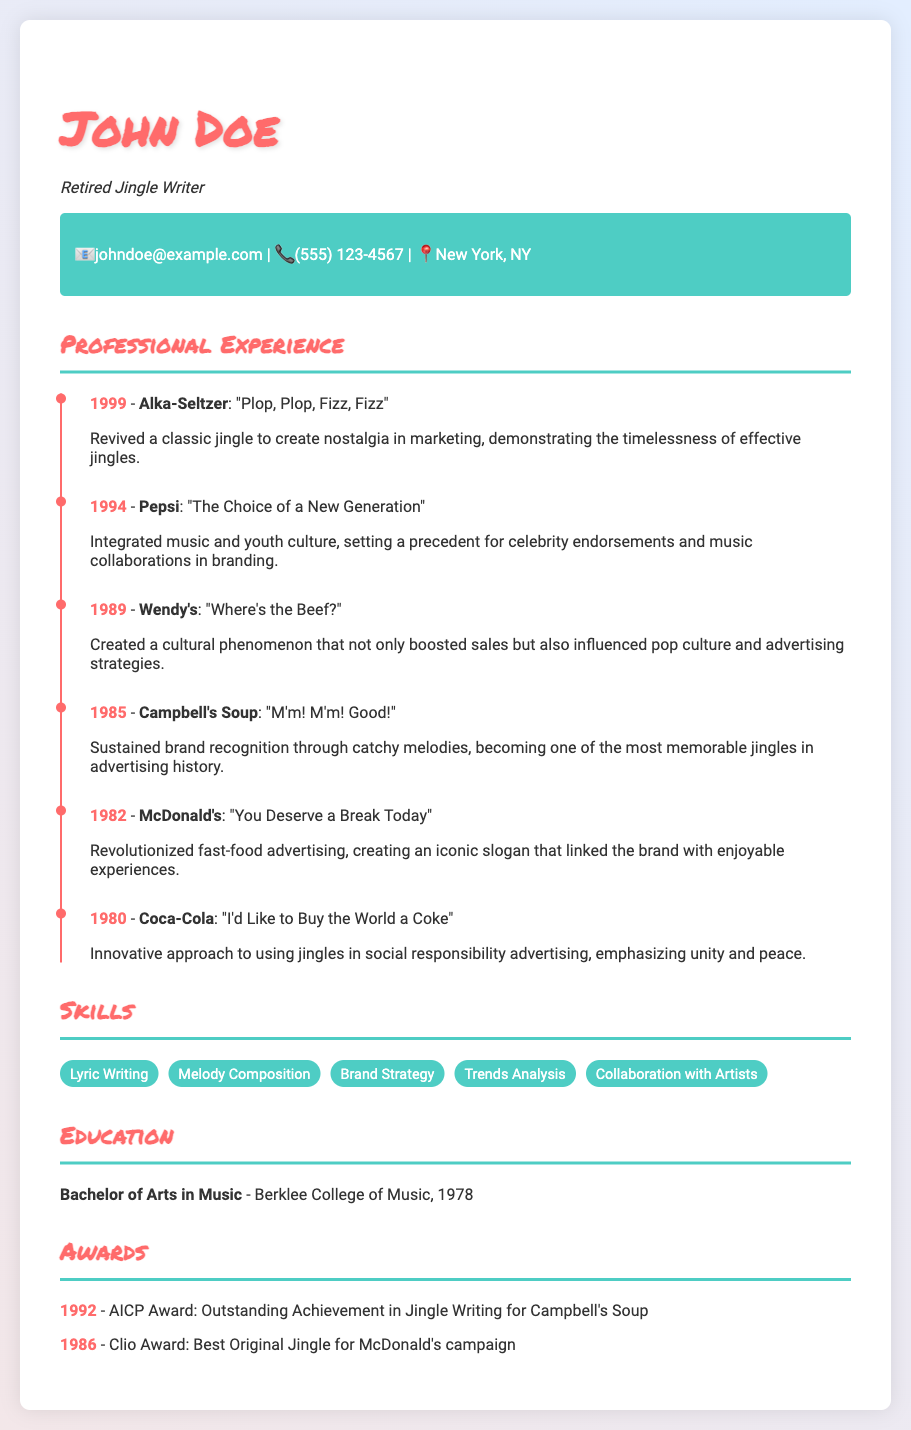what notable jingle was created for Coca-Cola in 1980? The document states that the jingle for Coca-Cola was "I'd Like to Buy the World a Coke."
Answer: I'd Like to Buy the World a Coke which company’s jingle included "Where's the Beef?" and was created in 1989? According to the document, the jingle "Where's the Beef?" was created for Wendy's in 1989.
Answer: Wendy's what year did John Doe write the jingle for McDonald's? The timeline in the document indicates that the jingle for McDonald's was written in 1982.
Answer: 1982 what is the total number of awards listed in the CV? The document lists two awards: the AICP Award and the Clio Award under the Awards section.
Answer: 2 which skill is associated with creating catchy melodies? The skills section mentions "Melody Composition" as a relevant skill for creating catchy melodies.
Answer: Melody Composition what impact did the jingle "The Choice of a New Generation" have on advertising? The document explains that this jingle set a precedent for celebrity endorsements and music collaborations in branding.
Answer: Celebrity endorsements what educational qualification does John Doe hold? The document specifies that John Doe holds a Bachelor of Arts in Music from Berklee College of Music.
Answer: Bachelor of Arts in Music in what year did John Doe revive the Alka-Seltzer jingle? The timeline indicates that John Doe revived the Alka-Seltzer jingle in 1999.
Answer: 1999 which jingle is noted for linking a brand with enjoyable experiences? The document mentions that the McDonald's jingle "You Deserve a Break Today" is noted for linking the brand with enjoyable experiences.
Answer: You Deserve a Break Today 